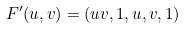Convert formula to latex. <formula><loc_0><loc_0><loc_500><loc_500>F ^ { \prime } ( u , v ) = ( u v , 1 , u , v , 1 )</formula> 